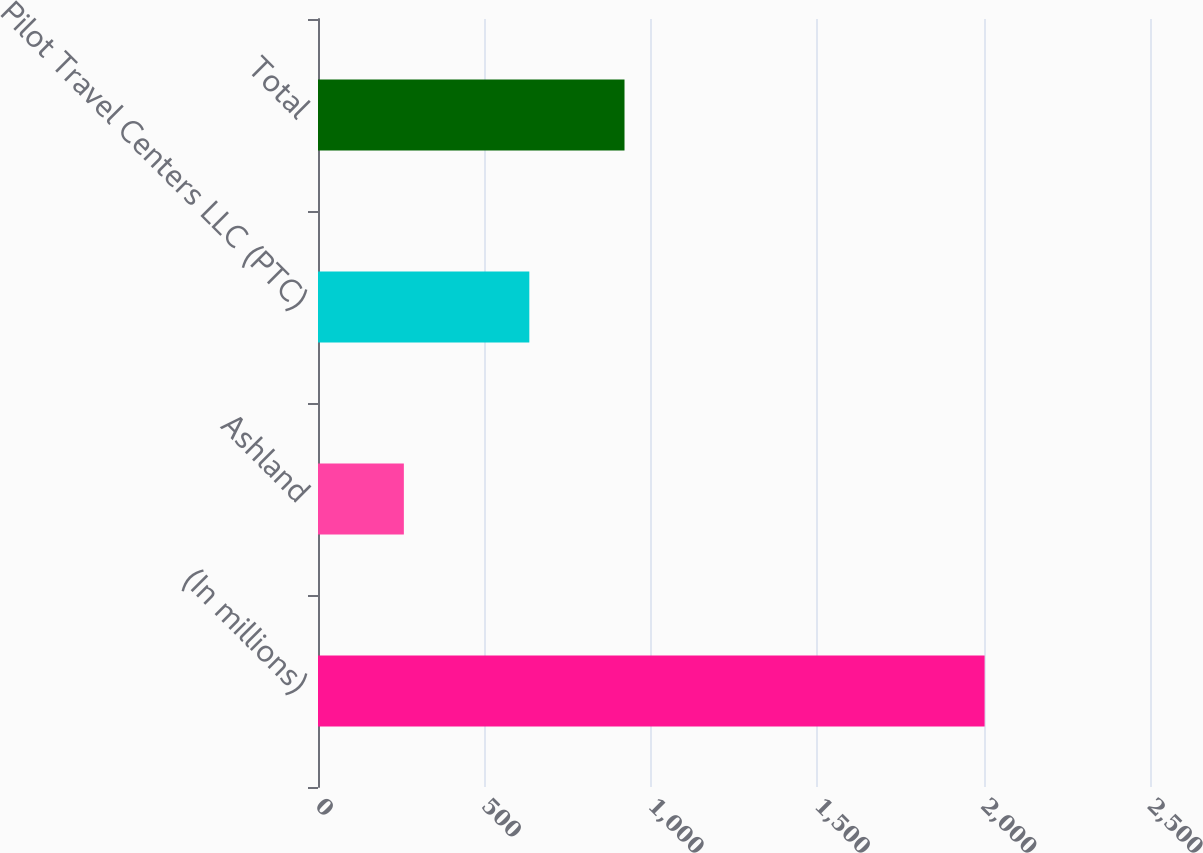Convert chart. <chart><loc_0><loc_0><loc_500><loc_500><bar_chart><fcel>(In millions)<fcel>Ashland<fcel>Pilot Travel Centers LLC (PTC)<fcel>Total<nl><fcel>2003<fcel>258<fcel>635<fcel>921<nl></chart> 